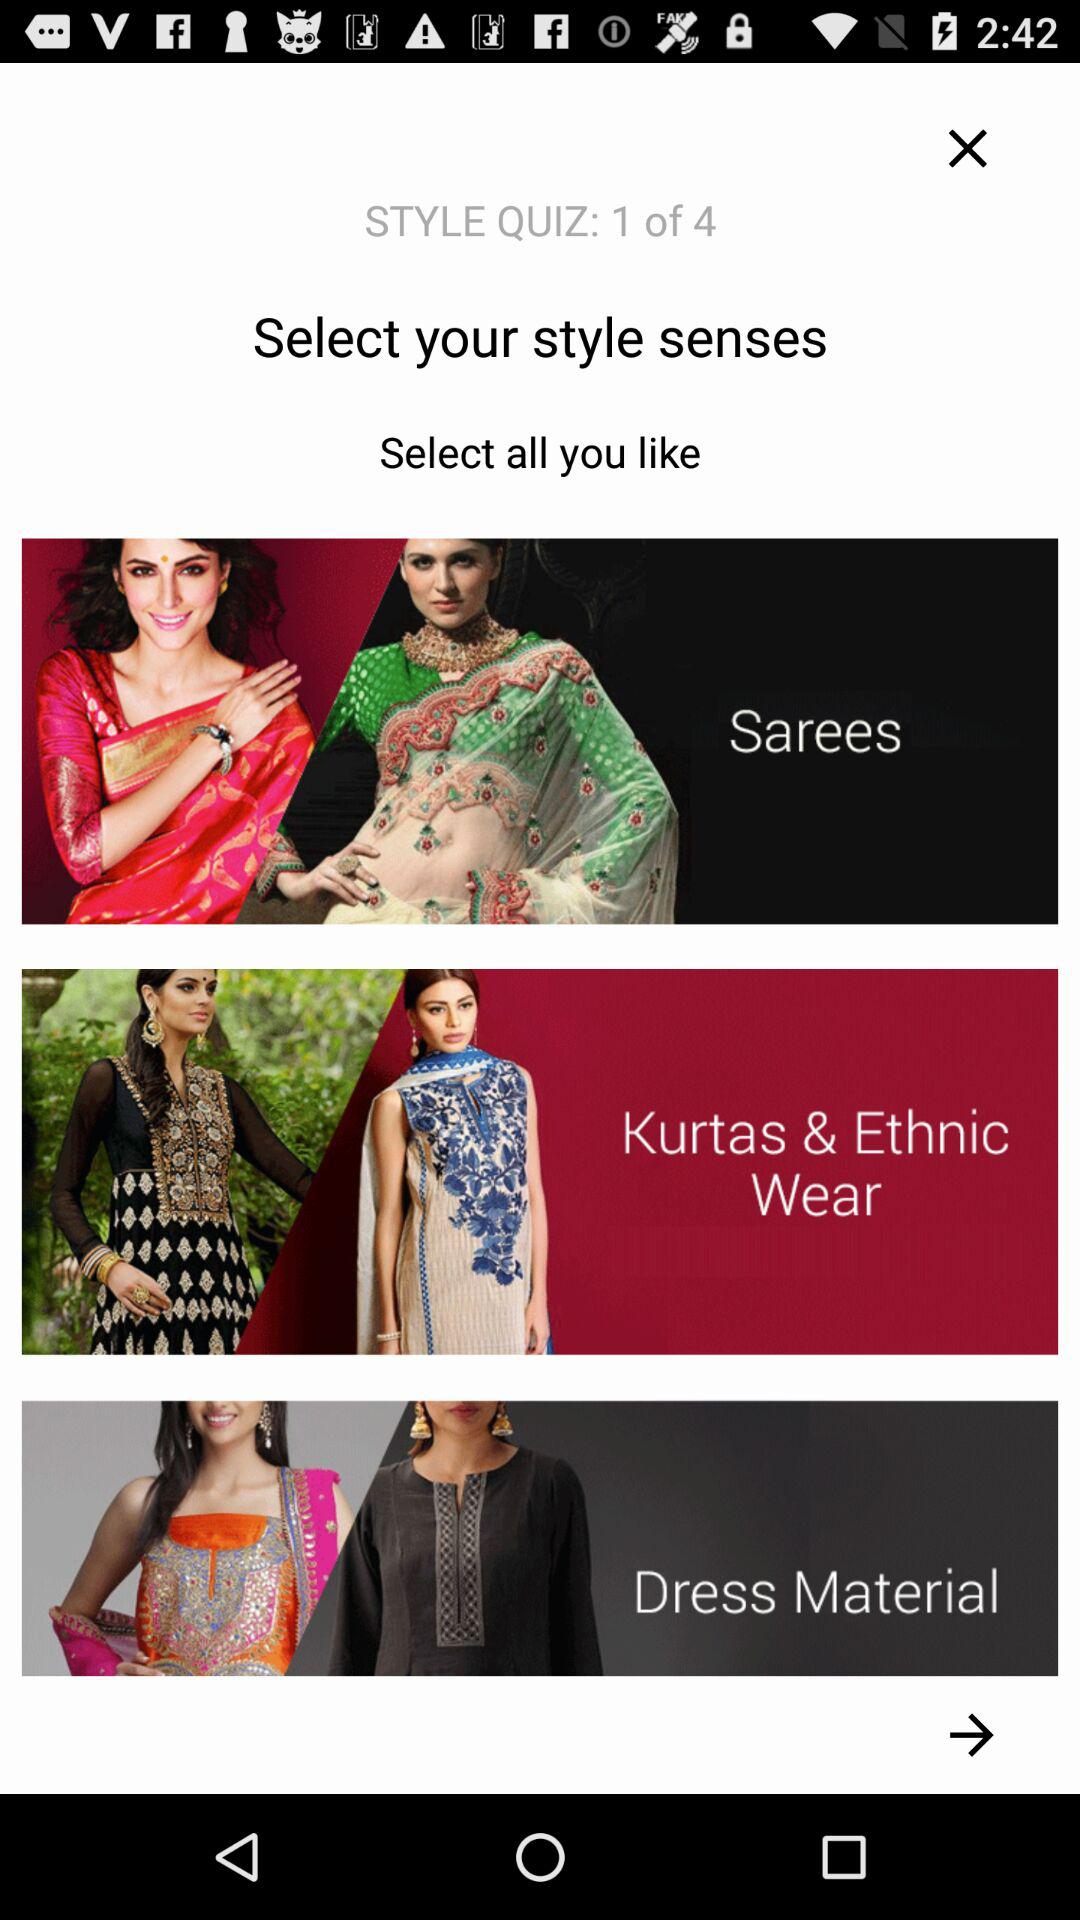What question number of the "STYLE" quiz are we on? You are on the first question of the "STYLE" quiz. 